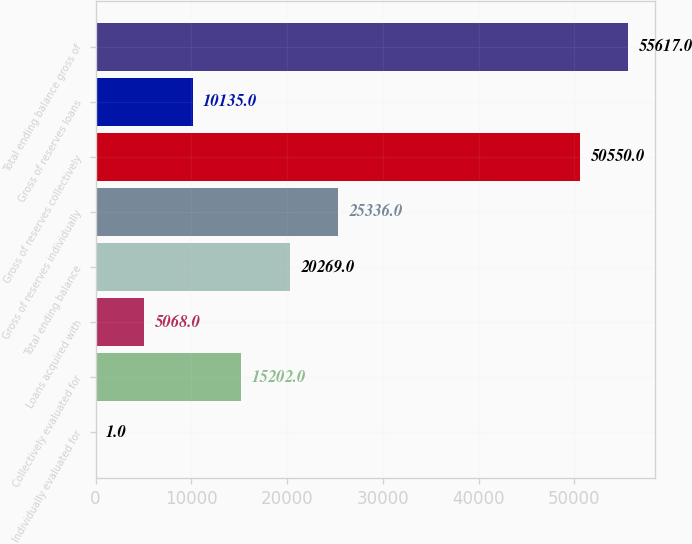Convert chart to OTSL. <chart><loc_0><loc_0><loc_500><loc_500><bar_chart><fcel>Individually evaluated for<fcel>Collectively evaluated for<fcel>Loans acquired with<fcel>Total ending balance<fcel>Gross of reserves individually<fcel>Gross of reserves collectively<fcel>Gross of reserves loans<fcel>Total ending balance gross of<nl><fcel>1<fcel>15202<fcel>5068<fcel>20269<fcel>25336<fcel>50550<fcel>10135<fcel>55617<nl></chart> 